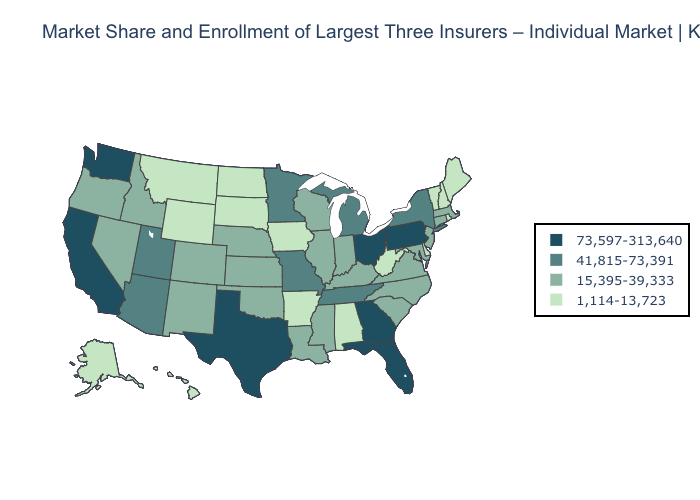Name the states that have a value in the range 41,815-73,391?
Be succinct. Arizona, Michigan, Minnesota, Missouri, New York, Tennessee, Utah. What is the value of Nebraska?
Quick response, please. 15,395-39,333. Name the states that have a value in the range 73,597-313,640?
Keep it brief. California, Florida, Georgia, Ohio, Pennsylvania, Texas, Washington. Among the states that border Arizona , does Utah have the lowest value?
Keep it brief. No. What is the highest value in states that border Massachusetts?
Be succinct. 41,815-73,391. Among the states that border Oklahoma , which have the highest value?
Answer briefly. Texas. Name the states that have a value in the range 41,815-73,391?
Be succinct. Arizona, Michigan, Minnesota, Missouri, New York, Tennessee, Utah. Among the states that border Wyoming , which have the highest value?
Give a very brief answer. Utah. Among the states that border Oregon , which have the highest value?
Be succinct. California, Washington. Does New York have the lowest value in the USA?
Be succinct. No. Does the first symbol in the legend represent the smallest category?
Concise answer only. No. Does the map have missing data?
Answer briefly. No. What is the value of North Carolina?
Write a very short answer. 15,395-39,333. What is the value of South Dakota?
Give a very brief answer. 1,114-13,723. Which states have the lowest value in the USA?
Quick response, please. Alabama, Alaska, Arkansas, Delaware, Hawaii, Iowa, Maine, Montana, New Hampshire, North Dakota, Rhode Island, South Dakota, Vermont, West Virginia, Wyoming. 